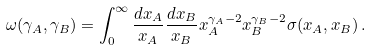<formula> <loc_0><loc_0><loc_500><loc_500>\omega ( \gamma _ { A } , \gamma _ { B } ) = \int _ { 0 } ^ { \infty } { \frac { d x _ { A } } { x _ { A } } } { \frac { d x _ { B } } { x _ { B } } } x _ { A } ^ { \gamma _ { A } - 2 } x _ { B } ^ { \gamma _ { B } - 2 } \sigma ( x _ { A } , x _ { B } ) \, .</formula> 